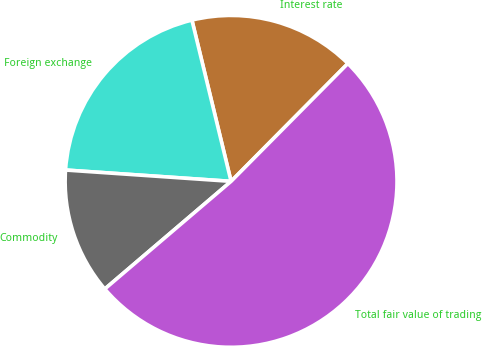Convert chart to OTSL. <chart><loc_0><loc_0><loc_500><loc_500><pie_chart><fcel>Interest rate<fcel>Foreign exchange<fcel>Commodity<fcel>Total fair value of trading<nl><fcel>16.22%<fcel>20.12%<fcel>12.32%<fcel>51.33%<nl></chart> 